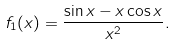Convert formula to latex. <formula><loc_0><loc_0><loc_500><loc_500>f _ { 1 } ( x ) = \frac { \sin x - x \cos x } { x ^ { 2 } } .</formula> 